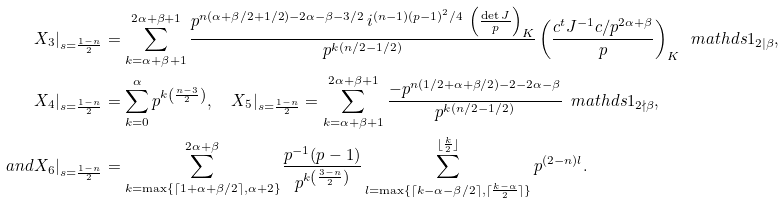<formula> <loc_0><loc_0><loc_500><loc_500>X _ { 3 } | _ { s = \frac { 1 - n } { 2 } } & = \sum _ { k = \alpha + \beta + 1 } ^ { 2 \alpha + \beta + 1 } \frac { p ^ { n ( \alpha + \beta / 2 + 1 / 2 ) - 2 \alpha - \beta - 3 / 2 } \, i ^ { ( n - 1 ) ( p - 1 ) ^ { 2 } / 4 } \, \left ( \frac { \det J } { p } \right ) _ { K } } { p ^ { k ( n / 2 - 1 / 2 ) } } \left ( \frac { c ^ { t } J ^ { - 1 } c / p ^ { 2 \alpha + \beta } } { p } \right ) _ { K } \, \ m a t h d s { 1 } _ { 2 | \beta } , \\ X _ { 4 } | _ { s = \frac { 1 - n } { 2 } } & = \sum _ { k = 0 } ^ { \alpha } p ^ { k \left ( \frac { n - 3 } { 2 } \right ) } , \quad X _ { 5 } | _ { s = \frac { 1 - n } { 2 } } = \sum _ { k = \alpha + \beta + 1 } ^ { 2 \alpha + \beta + 1 } \frac { - p ^ { n ( 1 / 2 + \alpha + \beta / 2 ) - 2 - 2 \alpha - \beta } } { p ^ { k ( n / 2 - 1 / 2 ) } } \, \ m a t h d s { 1 } _ { 2 \nmid \beta } , \\ a n d X _ { 6 } | _ { s = \frac { 1 - n } { 2 } } & = \sum _ { k = \max \{ \lceil 1 + \alpha + \beta / 2 \rceil , \alpha + 2 \} } ^ { 2 \alpha + \beta } \frac { p ^ { - 1 } ( p - 1 ) } { p ^ { k \left ( \frac { 3 - n } { 2 } \right ) } } \sum _ { l = \max \{ \lceil k - \alpha - \beta / 2 \rceil , \lceil \frac { k - \alpha } { 2 } \rceil \} } ^ { \lfloor \frac { k } { 2 } \rfloor } p ^ { ( 2 - n ) l } .</formula> 